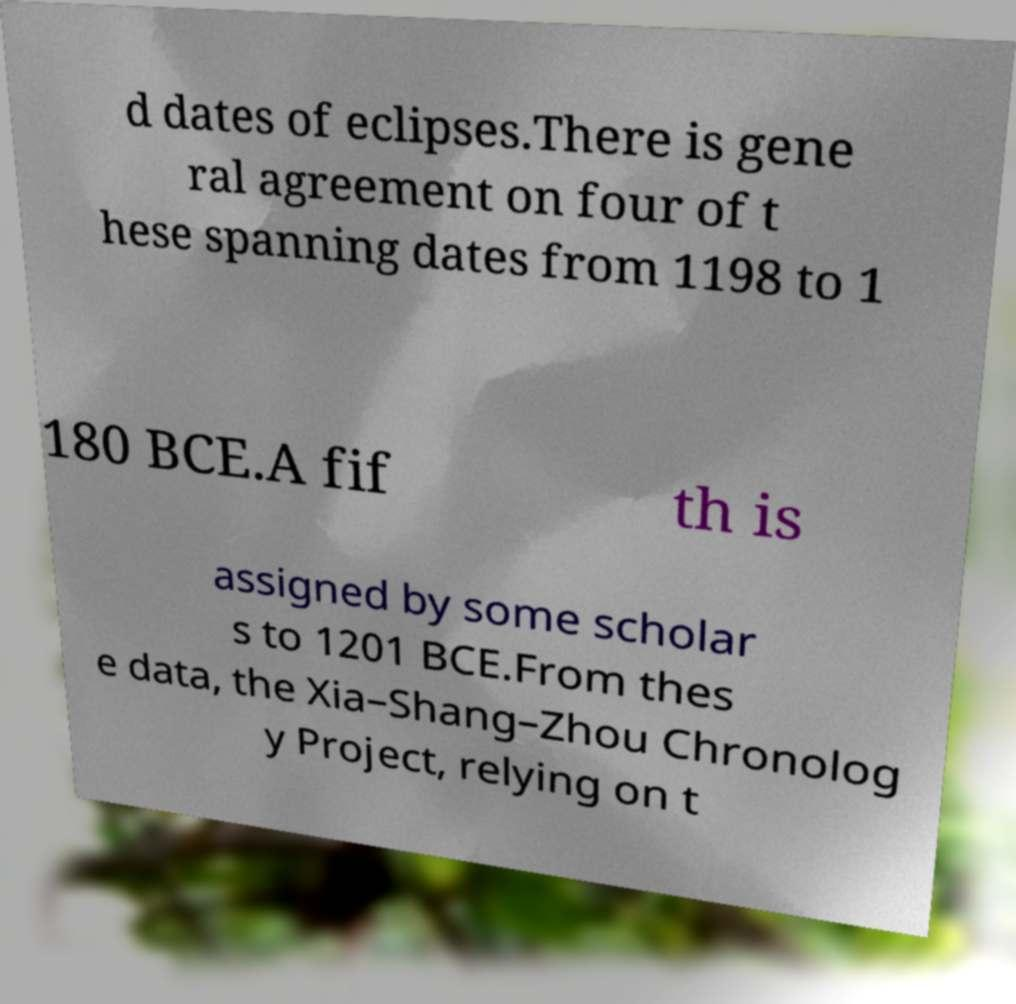Can you read and provide the text displayed in the image?This photo seems to have some interesting text. Can you extract and type it out for me? d dates of eclipses.There is gene ral agreement on four of t hese spanning dates from 1198 to 1 180 BCE.A fif th is assigned by some scholar s to 1201 BCE.From thes e data, the Xia–Shang–Zhou Chronolog y Project, relying on t 